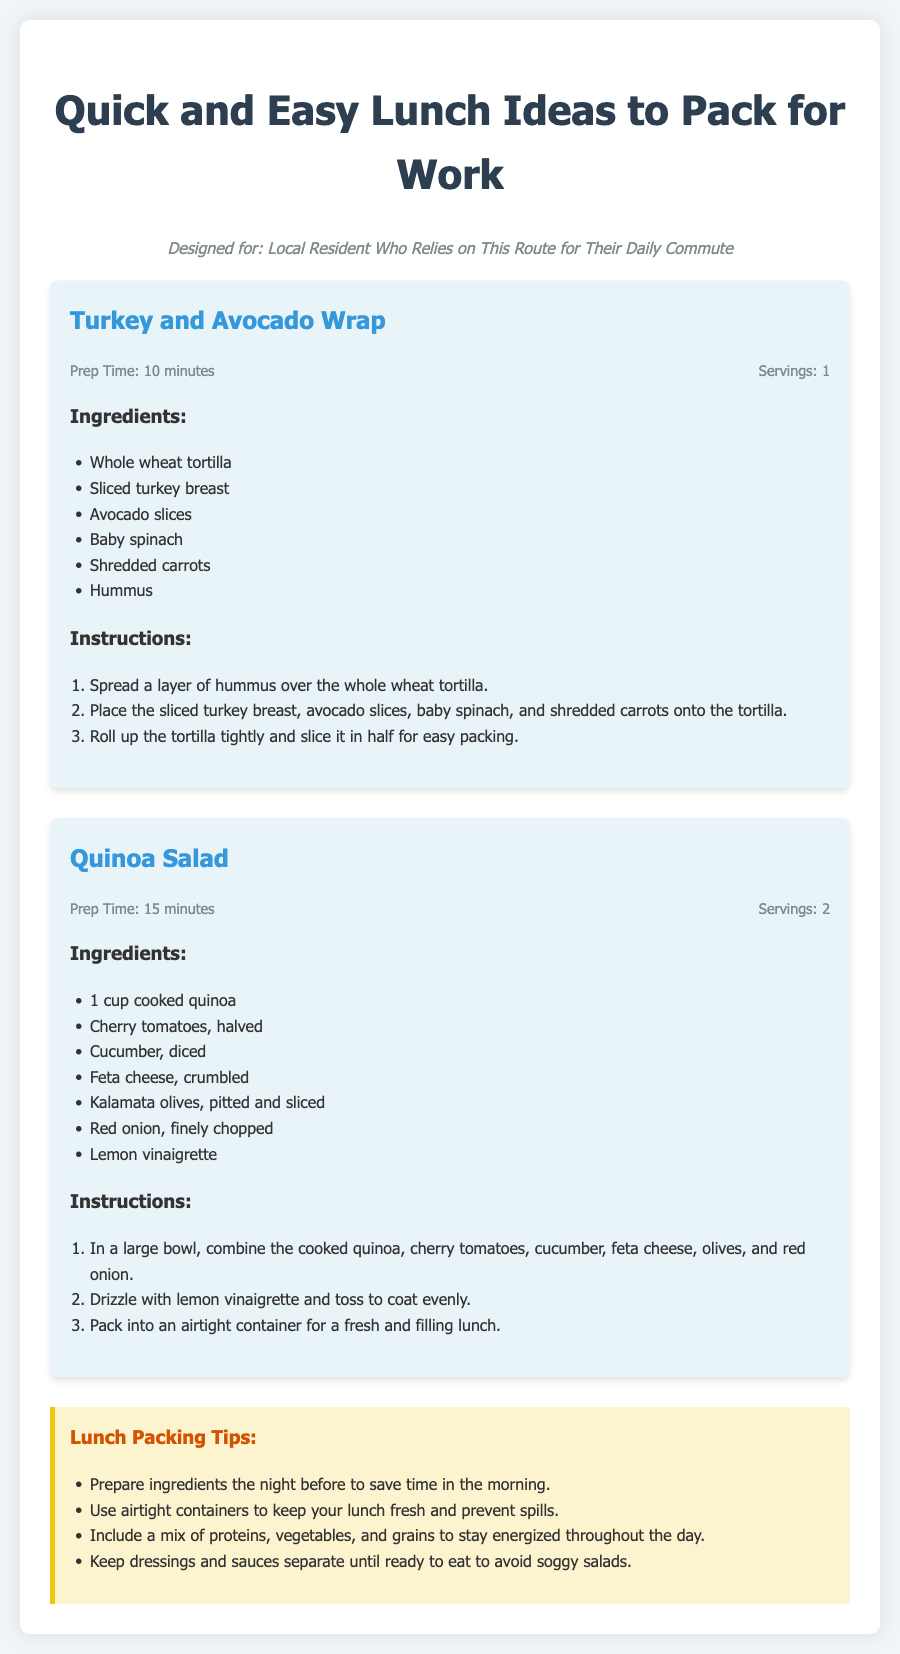what is the title of the document? The title is prominently displayed at the top of the document as "Quick and Easy Lunch Ideas to Pack for Work."
Answer: Quick and Easy Lunch Ideas to Pack for Work what is the prep time for the Turkey and Avocado Wrap? The prep time is specifically listed under the Turkey and Avocado Wrap section as 10 minutes.
Answer: 10 minutes how many servings does the Quinoa Salad recipe make? The number of servings is stated in the Quinoa Salad section as 2.
Answer: 2 what is one of the ingredients in the Turkey and Avocado Wrap? The ingredients are listed in a bulleted format, and one of them is sliced turkey breast.
Answer: Sliced turkey breast what is the last step in the Quinoa Salad instructions? The last step is provided in the numbered list of instructions, which indicates to pack it into an airtight container.
Answer: Pack into an airtight container what is the purpose of the tips section? The tips section provides advice on how to pack lunches efficiently and keep them fresh, making it unique to this recipe card type.
Answer: Lunch packing tips why should dressings be kept separate until ready to eat? This reasoning is found in the tips section, which states it prevents soggy salads.
Answer: To avoid soggy salads what color is the background of the recipe cards? The background color of the recipe cards is indicated as light blue in the design of the document.
Answer: Light blue how long does it take to prepare the Quinoa Salad? The prep time is clearly indicated in the Quinoa Salad section as 15 minutes.
Answer: 15 minutes 